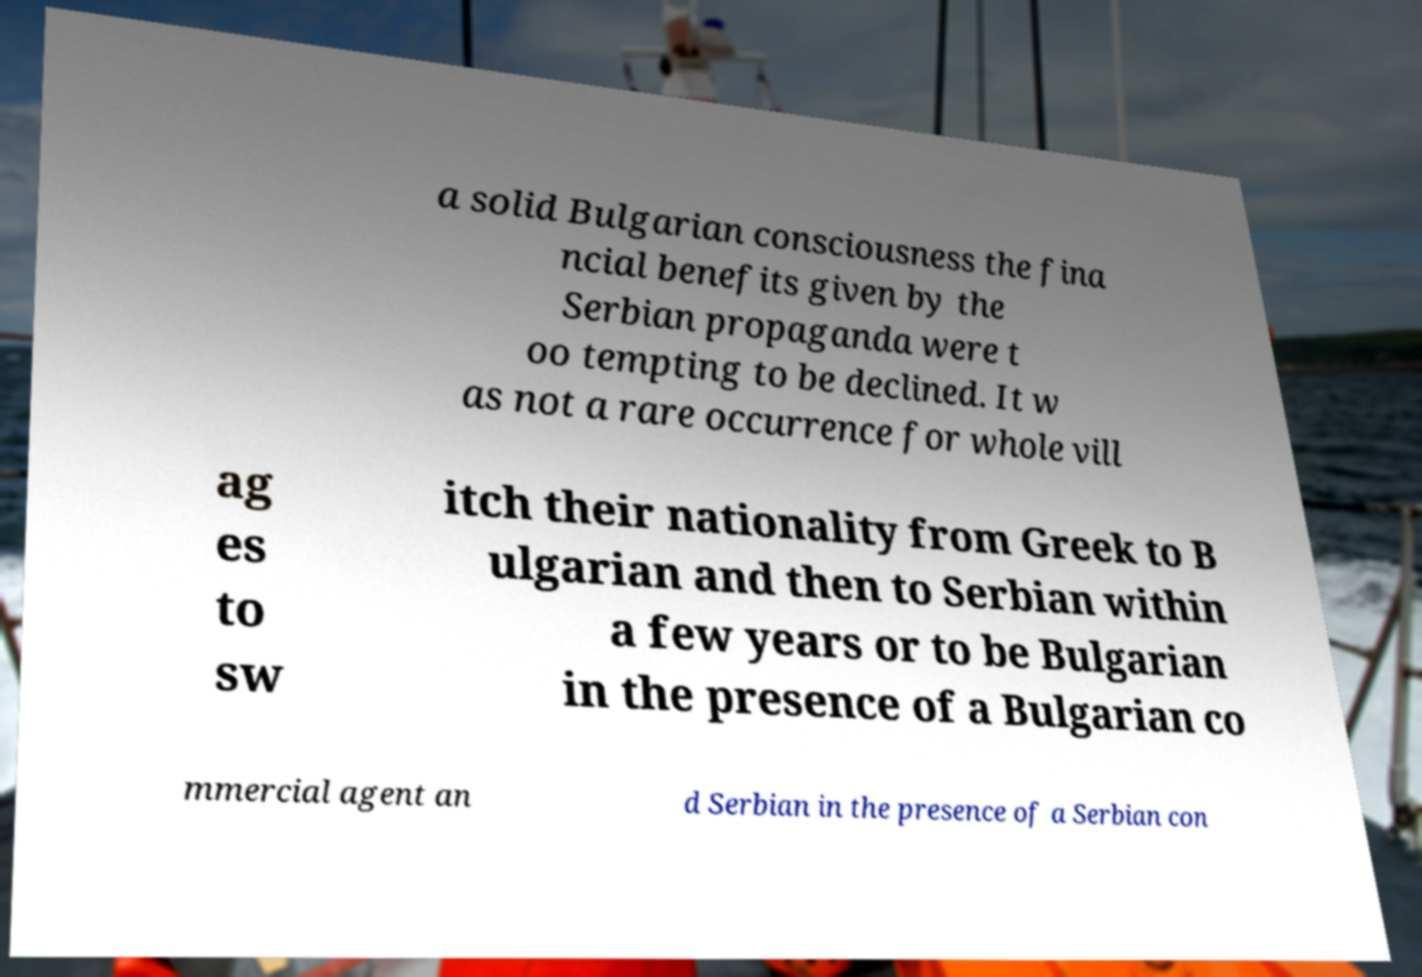Please identify and transcribe the text found in this image. a solid Bulgarian consciousness the fina ncial benefits given by the Serbian propaganda were t oo tempting to be declined. It w as not a rare occurrence for whole vill ag es to sw itch their nationality from Greek to B ulgarian and then to Serbian within a few years or to be Bulgarian in the presence of a Bulgarian co mmercial agent an d Serbian in the presence of a Serbian con 